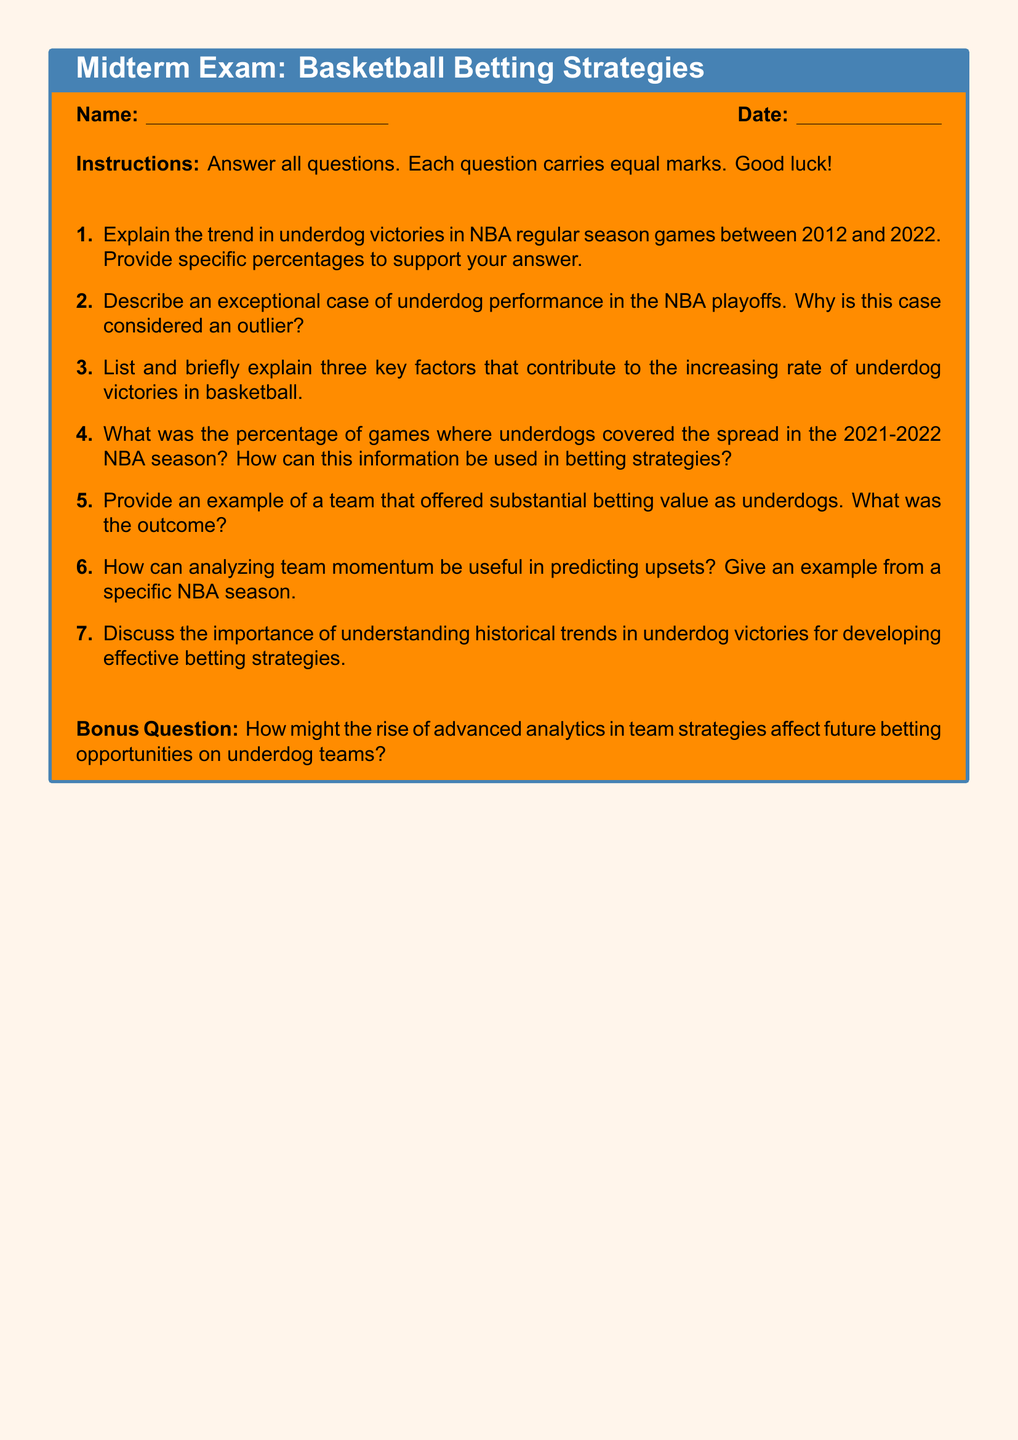What is the time period covered for underdog victories in the NBA mentioned in the document? The document states the period for underdog victories is from 2012 to 2022.
Answer: 2012 to 2022 What percentage of games did underdogs cover the spread in the 2021-2022 NBA season? This information is specifically requested in question 4 of the exam, implying a key statistic about underdog performance.
Answer: Percentage unspecified Name one key factor contributing to the increasing rate of underdog victories in basketball. The document provides a request to list three key factors, indicating their identification is essential.
Answer: Key factor unspecified What is the bonus question asking about? The bonus question relates to the impact of advanced analytics on future betting opportunities for underdog teams.
Answer: Advanced analytics What type of exam is this document presenting? The document explicitly describes itself as a midterm exam on basketball betting strategies.
Answer: Midterm exam In which section can you find the instructions for answering the exam questions? The instructions are located near the beginning of the document, guiding students on how to respond.
Answer: Instructions section How many key factors are students asked to briefly explain? The exam instructs students to explain three key factors contributing to underdog victories.
Answer: Three factors 